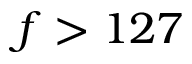<formula> <loc_0><loc_0><loc_500><loc_500>f > 1 2 7</formula> 